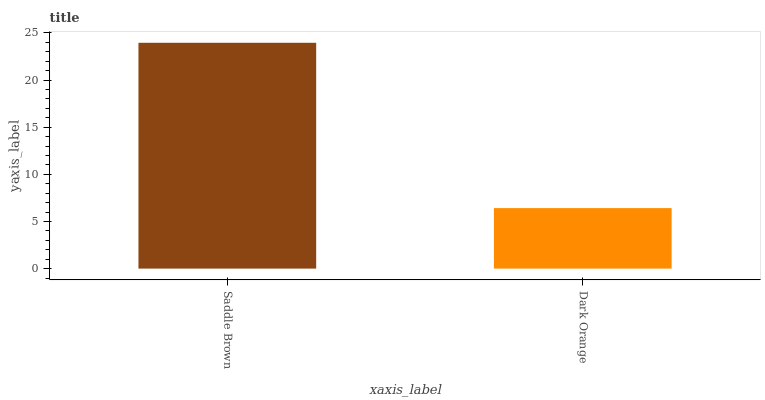Is Dark Orange the minimum?
Answer yes or no. Yes. Is Saddle Brown the maximum?
Answer yes or no. Yes. Is Dark Orange the maximum?
Answer yes or no. No. Is Saddle Brown greater than Dark Orange?
Answer yes or no. Yes. Is Dark Orange less than Saddle Brown?
Answer yes or no. Yes. Is Dark Orange greater than Saddle Brown?
Answer yes or no. No. Is Saddle Brown less than Dark Orange?
Answer yes or no. No. Is Saddle Brown the high median?
Answer yes or no. Yes. Is Dark Orange the low median?
Answer yes or no. Yes. Is Dark Orange the high median?
Answer yes or no. No. Is Saddle Brown the low median?
Answer yes or no. No. 